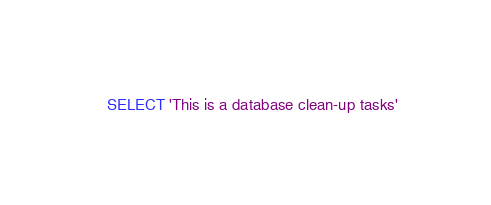<code> <loc_0><loc_0><loc_500><loc_500><_SQL_>SELECT 'This is a database clean-up tasks'</code> 